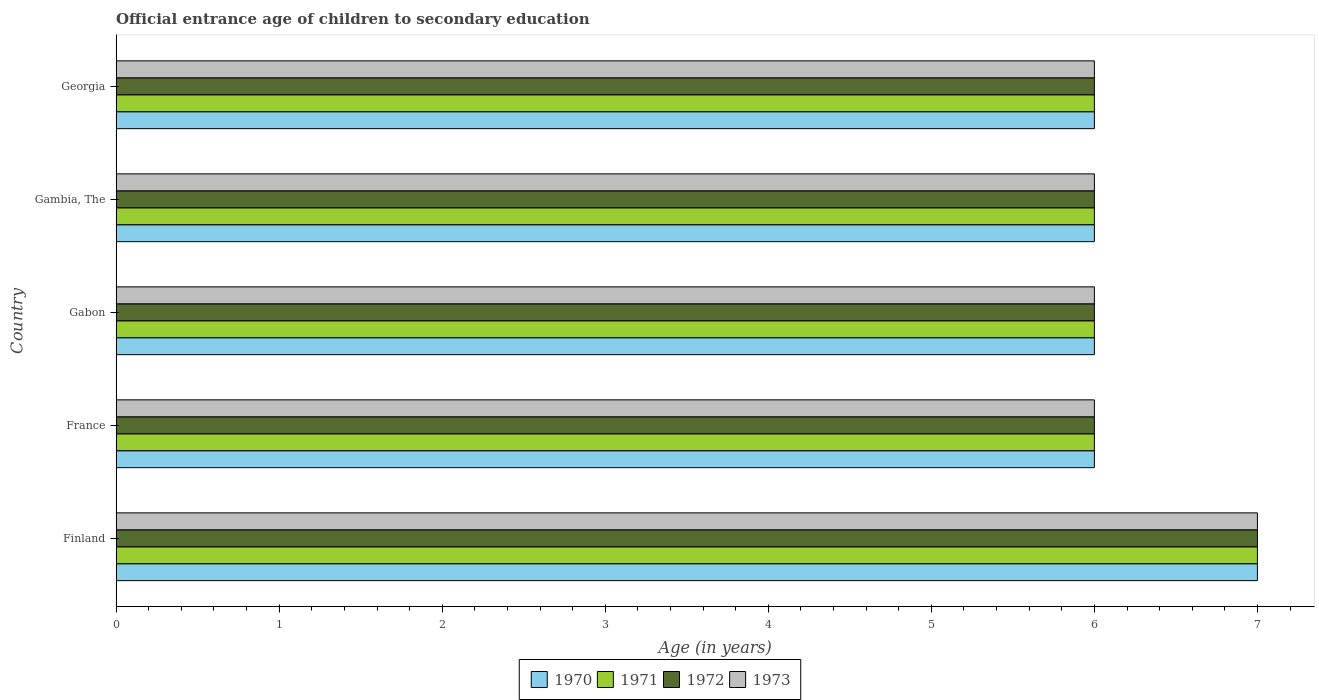Are the number of bars per tick equal to the number of legend labels?
Your response must be concise. Yes. How many bars are there on the 4th tick from the top?
Offer a very short reply. 4. What is the label of the 1st group of bars from the top?
Your answer should be compact. Georgia. In how many cases, is the number of bars for a given country not equal to the number of legend labels?
Keep it short and to the point. 0. What is the secondary school starting age of children in 1970 in Gabon?
Offer a terse response. 6. In which country was the secondary school starting age of children in 1972 maximum?
Your response must be concise. Finland. In which country was the secondary school starting age of children in 1971 minimum?
Ensure brevity in your answer.  France. What is the total secondary school starting age of children in 1971 in the graph?
Keep it short and to the point. 31. What is the difference between the secondary school starting age of children in 1971 in Gabon and that in Gambia, The?
Keep it short and to the point. 0. What is the average secondary school starting age of children in 1973 per country?
Provide a succinct answer. 6.2. What is the difference between the secondary school starting age of children in 1973 and secondary school starting age of children in 1971 in Gambia, The?
Your answer should be compact. 0. In how many countries, is the secondary school starting age of children in 1972 greater than 4.6 years?
Make the answer very short. 5. What is the ratio of the secondary school starting age of children in 1971 in Gabon to that in Gambia, The?
Ensure brevity in your answer.  1. Is the difference between the secondary school starting age of children in 1973 in France and Gambia, The greater than the difference between the secondary school starting age of children in 1971 in France and Gambia, The?
Give a very brief answer. No. What is the difference between the highest and the second highest secondary school starting age of children in 1972?
Provide a short and direct response. 1. In how many countries, is the secondary school starting age of children in 1971 greater than the average secondary school starting age of children in 1971 taken over all countries?
Your answer should be very brief. 1. Is it the case that in every country, the sum of the secondary school starting age of children in 1971 and secondary school starting age of children in 1973 is greater than the sum of secondary school starting age of children in 1972 and secondary school starting age of children in 1970?
Offer a very short reply. No. What does the 2nd bar from the top in Finland represents?
Offer a terse response. 1972. What does the 4th bar from the bottom in France represents?
Your answer should be very brief. 1973. How many bars are there?
Ensure brevity in your answer.  20. Does the graph contain grids?
Offer a terse response. No. Where does the legend appear in the graph?
Offer a very short reply. Bottom center. How many legend labels are there?
Offer a very short reply. 4. How are the legend labels stacked?
Offer a very short reply. Horizontal. What is the title of the graph?
Provide a succinct answer. Official entrance age of children to secondary education. Does "1989" appear as one of the legend labels in the graph?
Your answer should be very brief. No. What is the label or title of the X-axis?
Offer a terse response. Age (in years). What is the Age (in years) in 1972 in Finland?
Keep it short and to the point. 7. What is the Age (in years) of 1971 in France?
Provide a short and direct response. 6. What is the Age (in years) in 1970 in Gabon?
Keep it short and to the point. 6. What is the Age (in years) in 1971 in Gabon?
Your response must be concise. 6. What is the Age (in years) in 1972 in Gabon?
Your answer should be compact. 6. What is the Age (in years) of 1973 in Gabon?
Give a very brief answer. 6. What is the Age (in years) in 1970 in Gambia, The?
Provide a short and direct response. 6. What is the Age (in years) in 1971 in Gambia, The?
Keep it short and to the point. 6. What is the Age (in years) in 1972 in Gambia, The?
Provide a short and direct response. 6. What is the Age (in years) of 1973 in Gambia, The?
Provide a succinct answer. 6. What is the Age (in years) in 1970 in Georgia?
Offer a very short reply. 6. What is the Age (in years) in 1971 in Georgia?
Your response must be concise. 6. What is the Age (in years) in 1972 in Georgia?
Your answer should be compact. 6. What is the Age (in years) in 1973 in Georgia?
Ensure brevity in your answer.  6. Across all countries, what is the maximum Age (in years) in 1971?
Your response must be concise. 7. Across all countries, what is the maximum Age (in years) in 1973?
Ensure brevity in your answer.  7. Across all countries, what is the minimum Age (in years) in 1972?
Your answer should be compact. 6. What is the total Age (in years) in 1970 in the graph?
Provide a succinct answer. 31. What is the total Age (in years) of 1971 in the graph?
Make the answer very short. 31. What is the difference between the Age (in years) in 1970 in Finland and that in France?
Your response must be concise. 1. What is the difference between the Age (in years) in 1971 in Finland and that in France?
Provide a succinct answer. 1. What is the difference between the Age (in years) of 1970 in Finland and that in Gabon?
Your answer should be compact. 1. What is the difference between the Age (in years) in 1971 in Finland and that in Gabon?
Keep it short and to the point. 1. What is the difference between the Age (in years) of 1973 in Finland and that in Gabon?
Make the answer very short. 1. What is the difference between the Age (in years) in 1971 in Finland and that in Gambia, The?
Make the answer very short. 1. What is the difference between the Age (in years) in 1972 in Finland and that in Gambia, The?
Offer a terse response. 1. What is the difference between the Age (in years) in 1973 in Finland and that in Gambia, The?
Provide a short and direct response. 1. What is the difference between the Age (in years) in 1971 in Finland and that in Georgia?
Your response must be concise. 1. What is the difference between the Age (in years) of 1970 in France and that in Gabon?
Offer a terse response. 0. What is the difference between the Age (in years) of 1973 in France and that in Gabon?
Your answer should be compact. 0. What is the difference between the Age (in years) of 1971 in France and that in Gambia, The?
Your answer should be compact. 0. What is the difference between the Age (in years) of 1973 in France and that in Gambia, The?
Your response must be concise. 0. What is the difference between the Age (in years) in 1970 in France and that in Georgia?
Your response must be concise. 0. What is the difference between the Age (in years) in 1973 in France and that in Georgia?
Give a very brief answer. 0. What is the difference between the Age (in years) in 1971 in Gabon and that in Gambia, The?
Offer a terse response. 0. What is the difference between the Age (in years) in 1971 in Gabon and that in Georgia?
Make the answer very short. 0. What is the difference between the Age (in years) in 1972 in Gabon and that in Georgia?
Keep it short and to the point. 0. What is the difference between the Age (in years) in 1973 in Gabon and that in Georgia?
Your answer should be compact. 0. What is the difference between the Age (in years) in 1971 in Finland and the Age (in years) in 1973 in France?
Offer a very short reply. 1. What is the difference between the Age (in years) of 1970 in Finland and the Age (in years) of 1971 in Gabon?
Provide a short and direct response. 1. What is the difference between the Age (in years) in 1971 in Finland and the Age (in years) in 1972 in Gabon?
Keep it short and to the point. 1. What is the difference between the Age (in years) of 1971 in Finland and the Age (in years) of 1973 in Gabon?
Make the answer very short. 1. What is the difference between the Age (in years) in 1972 in Finland and the Age (in years) in 1973 in Gabon?
Ensure brevity in your answer.  1. What is the difference between the Age (in years) of 1970 in Finland and the Age (in years) of 1972 in Gambia, The?
Ensure brevity in your answer.  1. What is the difference between the Age (in years) in 1970 in Finland and the Age (in years) in 1973 in Gambia, The?
Offer a very short reply. 1. What is the difference between the Age (in years) of 1971 in Finland and the Age (in years) of 1972 in Gambia, The?
Offer a terse response. 1. What is the difference between the Age (in years) in 1972 in Finland and the Age (in years) in 1973 in Gambia, The?
Offer a very short reply. 1. What is the difference between the Age (in years) of 1970 in Finland and the Age (in years) of 1971 in Georgia?
Ensure brevity in your answer.  1. What is the difference between the Age (in years) of 1970 in Finland and the Age (in years) of 1972 in Georgia?
Make the answer very short. 1. What is the difference between the Age (in years) of 1971 in Finland and the Age (in years) of 1972 in Georgia?
Your answer should be compact. 1. What is the difference between the Age (in years) of 1970 in France and the Age (in years) of 1972 in Gabon?
Make the answer very short. 0. What is the difference between the Age (in years) of 1970 in France and the Age (in years) of 1973 in Gabon?
Ensure brevity in your answer.  0. What is the difference between the Age (in years) of 1971 in France and the Age (in years) of 1972 in Gabon?
Ensure brevity in your answer.  0. What is the difference between the Age (in years) in 1970 in France and the Age (in years) in 1973 in Gambia, The?
Ensure brevity in your answer.  0. What is the difference between the Age (in years) of 1971 in France and the Age (in years) of 1973 in Gambia, The?
Offer a very short reply. 0. What is the difference between the Age (in years) in 1972 in France and the Age (in years) in 1973 in Gambia, The?
Offer a terse response. 0. What is the difference between the Age (in years) in 1970 in France and the Age (in years) in 1971 in Georgia?
Make the answer very short. 0. What is the difference between the Age (in years) of 1970 in France and the Age (in years) of 1972 in Georgia?
Your answer should be very brief. 0. What is the difference between the Age (in years) in 1972 in France and the Age (in years) in 1973 in Georgia?
Your response must be concise. 0. What is the difference between the Age (in years) of 1970 in Gabon and the Age (in years) of 1971 in Gambia, The?
Keep it short and to the point. 0. What is the difference between the Age (in years) in 1970 in Gabon and the Age (in years) in 1973 in Gambia, The?
Give a very brief answer. 0. What is the difference between the Age (in years) of 1971 in Gabon and the Age (in years) of 1973 in Gambia, The?
Offer a terse response. 0. What is the difference between the Age (in years) in 1972 in Gabon and the Age (in years) in 1973 in Gambia, The?
Make the answer very short. 0. What is the difference between the Age (in years) of 1970 in Gabon and the Age (in years) of 1972 in Georgia?
Keep it short and to the point. 0. What is the difference between the Age (in years) of 1970 in Gabon and the Age (in years) of 1973 in Georgia?
Keep it short and to the point. 0. What is the difference between the Age (in years) of 1971 in Gabon and the Age (in years) of 1972 in Georgia?
Provide a short and direct response. 0. What is the difference between the Age (in years) of 1972 in Gabon and the Age (in years) of 1973 in Georgia?
Your answer should be very brief. 0. What is the difference between the Age (in years) of 1970 in Gambia, The and the Age (in years) of 1971 in Georgia?
Give a very brief answer. 0. What is the difference between the Age (in years) of 1970 in Gambia, The and the Age (in years) of 1972 in Georgia?
Your response must be concise. 0. What is the difference between the Age (in years) in 1970 in Gambia, The and the Age (in years) in 1973 in Georgia?
Offer a very short reply. 0. What is the difference between the Age (in years) of 1971 in Gambia, The and the Age (in years) of 1972 in Georgia?
Your response must be concise. 0. What is the difference between the Age (in years) in 1972 in Gambia, The and the Age (in years) in 1973 in Georgia?
Provide a short and direct response. 0. What is the average Age (in years) of 1971 per country?
Make the answer very short. 6.2. What is the average Age (in years) in 1972 per country?
Make the answer very short. 6.2. What is the average Age (in years) in 1973 per country?
Ensure brevity in your answer.  6.2. What is the difference between the Age (in years) in 1970 and Age (in years) in 1972 in Finland?
Ensure brevity in your answer.  0. What is the difference between the Age (in years) in 1970 and Age (in years) in 1973 in Finland?
Provide a short and direct response. 0. What is the difference between the Age (in years) in 1972 and Age (in years) in 1973 in Finland?
Your response must be concise. 0. What is the difference between the Age (in years) in 1970 and Age (in years) in 1973 in France?
Keep it short and to the point. 0. What is the difference between the Age (in years) of 1971 and Age (in years) of 1972 in France?
Your answer should be compact. 0. What is the difference between the Age (in years) in 1972 and Age (in years) in 1973 in France?
Keep it short and to the point. 0. What is the difference between the Age (in years) of 1970 and Age (in years) of 1972 in Gabon?
Offer a very short reply. 0. What is the difference between the Age (in years) of 1971 and Age (in years) of 1972 in Gabon?
Offer a terse response. 0. What is the difference between the Age (in years) in 1971 and Age (in years) in 1973 in Gabon?
Your answer should be compact. 0. What is the difference between the Age (in years) in 1970 and Age (in years) in 1971 in Gambia, The?
Provide a short and direct response. 0. What is the difference between the Age (in years) in 1970 and Age (in years) in 1972 in Gambia, The?
Your response must be concise. 0. What is the difference between the Age (in years) in 1970 and Age (in years) in 1973 in Gambia, The?
Provide a succinct answer. 0. What is the difference between the Age (in years) of 1971 and Age (in years) of 1973 in Gambia, The?
Provide a short and direct response. 0. What is the difference between the Age (in years) of 1970 and Age (in years) of 1971 in Georgia?
Your answer should be very brief. 0. What is the difference between the Age (in years) in 1970 and Age (in years) in 1972 in Georgia?
Give a very brief answer. 0. What is the difference between the Age (in years) of 1970 and Age (in years) of 1973 in Georgia?
Provide a short and direct response. 0. What is the difference between the Age (in years) of 1971 and Age (in years) of 1972 in Georgia?
Offer a terse response. 0. What is the difference between the Age (in years) of 1971 and Age (in years) of 1973 in Georgia?
Offer a terse response. 0. What is the ratio of the Age (in years) of 1972 in Finland to that in France?
Offer a very short reply. 1.17. What is the ratio of the Age (in years) of 1970 in Finland to that in Gabon?
Keep it short and to the point. 1.17. What is the ratio of the Age (in years) of 1971 in Finland to that in Gabon?
Offer a very short reply. 1.17. What is the ratio of the Age (in years) of 1973 in Finland to that in Gabon?
Ensure brevity in your answer.  1.17. What is the ratio of the Age (in years) of 1970 in Finland to that in Gambia, The?
Make the answer very short. 1.17. What is the ratio of the Age (in years) of 1971 in Finland to that in Gambia, The?
Make the answer very short. 1.17. What is the ratio of the Age (in years) in 1973 in Finland to that in Gambia, The?
Your response must be concise. 1.17. What is the ratio of the Age (in years) in 1973 in Finland to that in Georgia?
Your answer should be compact. 1.17. What is the ratio of the Age (in years) in 1970 in France to that in Gabon?
Make the answer very short. 1. What is the ratio of the Age (in years) in 1972 in France to that in Gabon?
Offer a very short reply. 1. What is the ratio of the Age (in years) of 1970 in France to that in Gambia, The?
Offer a very short reply. 1. What is the ratio of the Age (in years) of 1971 in France to that in Gambia, The?
Offer a terse response. 1. What is the ratio of the Age (in years) in 1972 in France to that in Gambia, The?
Your response must be concise. 1. What is the ratio of the Age (in years) of 1970 in France to that in Georgia?
Your answer should be compact. 1. What is the ratio of the Age (in years) in 1972 in France to that in Georgia?
Provide a succinct answer. 1. What is the ratio of the Age (in years) in 1970 in Gabon to that in Georgia?
Keep it short and to the point. 1. What is the ratio of the Age (in years) in 1972 in Gabon to that in Georgia?
Make the answer very short. 1. What is the difference between the highest and the second highest Age (in years) of 1970?
Your answer should be compact. 1. What is the difference between the highest and the second highest Age (in years) of 1972?
Your answer should be very brief. 1. What is the difference between the highest and the second highest Age (in years) in 1973?
Your response must be concise. 1. What is the difference between the highest and the lowest Age (in years) of 1970?
Your answer should be very brief. 1. What is the difference between the highest and the lowest Age (in years) in 1971?
Your response must be concise. 1. What is the difference between the highest and the lowest Age (in years) in 1972?
Give a very brief answer. 1. 